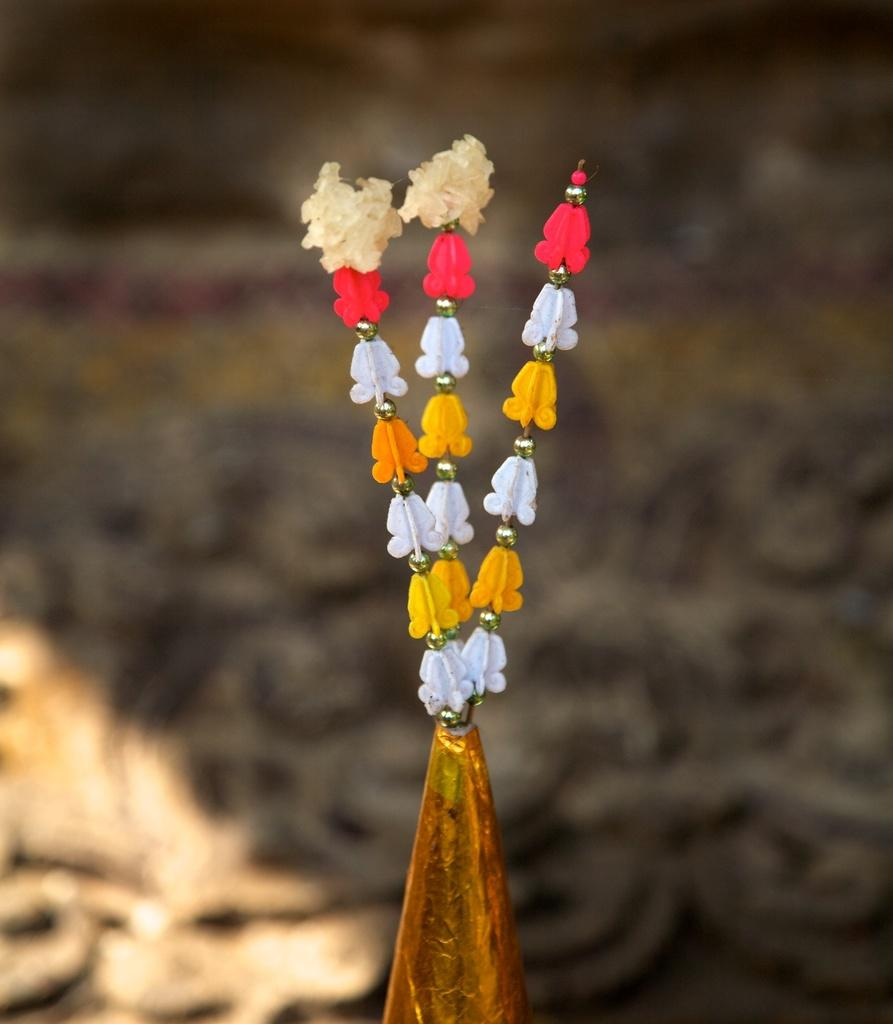What is the main subject in the image? There is an object in the image. Can you describe the appearance of the object? The object has multiple colors. What can be observed about the background of the image? The background of the image is blurred. What type of apparel is the sister wearing in the image? There is no reference to a sister or any apparel in the image, so it's not possible to answer that question. 